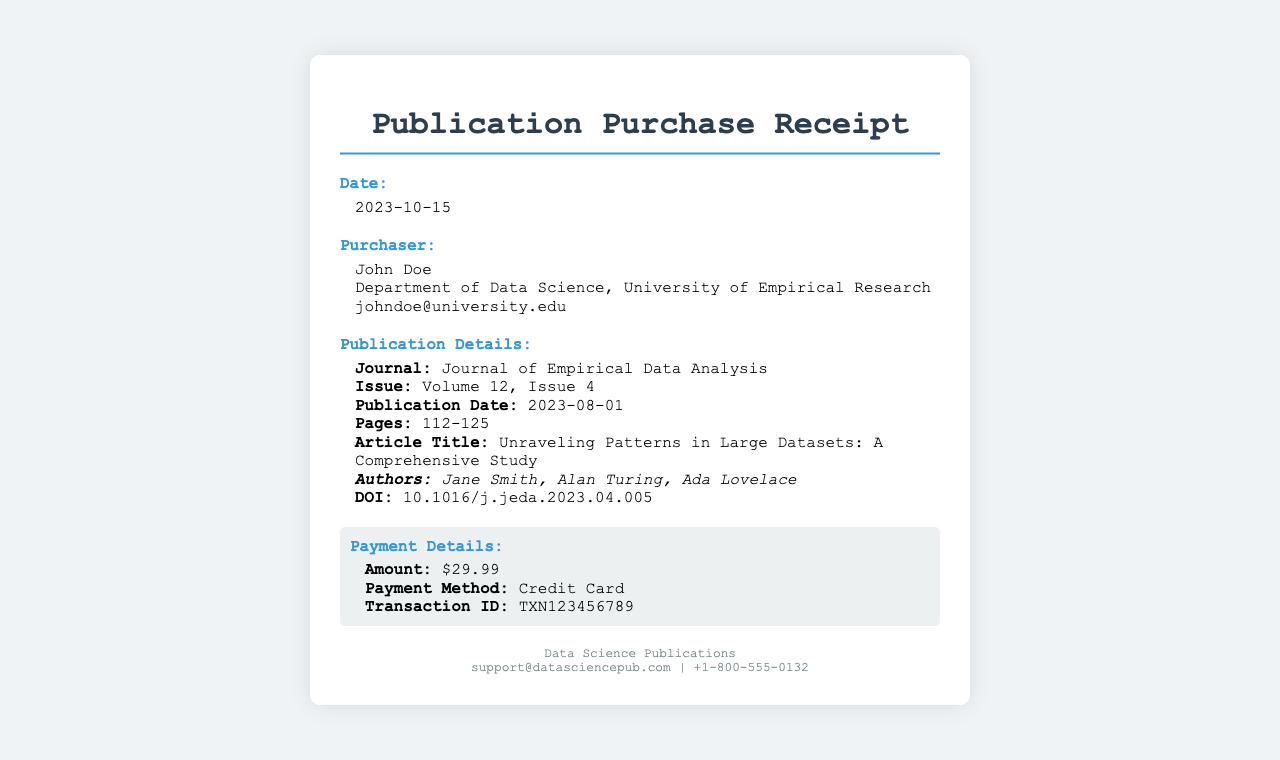What is the date of the purchase? The date of the purchase is specified in the document and is clearly stated.
Answer: 2023-10-15 Who is the purchaser? The document lists the name of the purchaser, which is a key detail to identify the transaction.
Answer: John Doe What is the DOI of the publication? The DOI is a unique identifier for the publication and is explicitly provided in the document.
Answer: 10.1016/j.jeda.2023.04.005 What is the publication date of the journal issue? The publication date indicates when the issue was released, which is noted in the document.
Answer: 2023-08-01 How many pages does the article span? The document provides specific page numbers, indicating the length of the article in the journal.
Answer: 112-125 What is the title of the article? The title is an important aspect of publication details, which is directly stated in the receipt.
Answer: Unraveling Patterns in Large Datasets: A Comprehensive Study What was the payment method? The payment method indicates how the transaction was completed and is recorded in the receipt.
Answer: Credit Card What was the amount charged for the publication? The amount reflects the cost of the purchase and is clearly listed in the payment details.
Answer: $29.99 What is the transaction ID? The transaction ID is a unique reference for the payment, included in the payment details section.
Answer: TXN123456789 